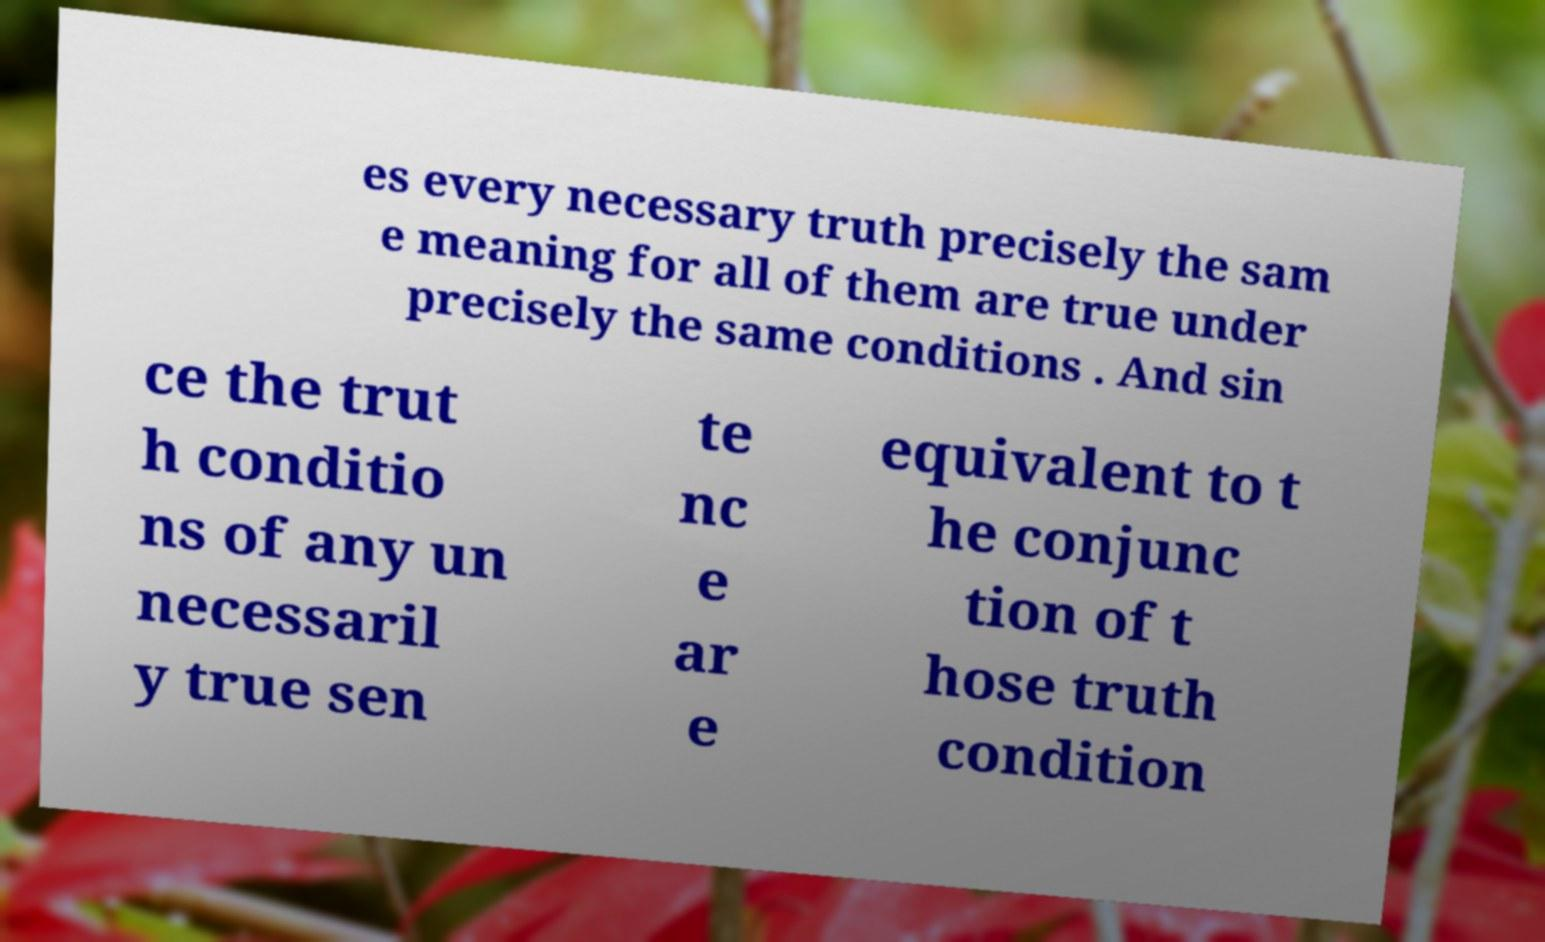I need the written content from this picture converted into text. Can you do that? es every necessary truth precisely the sam e meaning for all of them are true under precisely the same conditions . And sin ce the trut h conditio ns of any un necessaril y true sen te nc e ar e equivalent to t he conjunc tion of t hose truth condition 